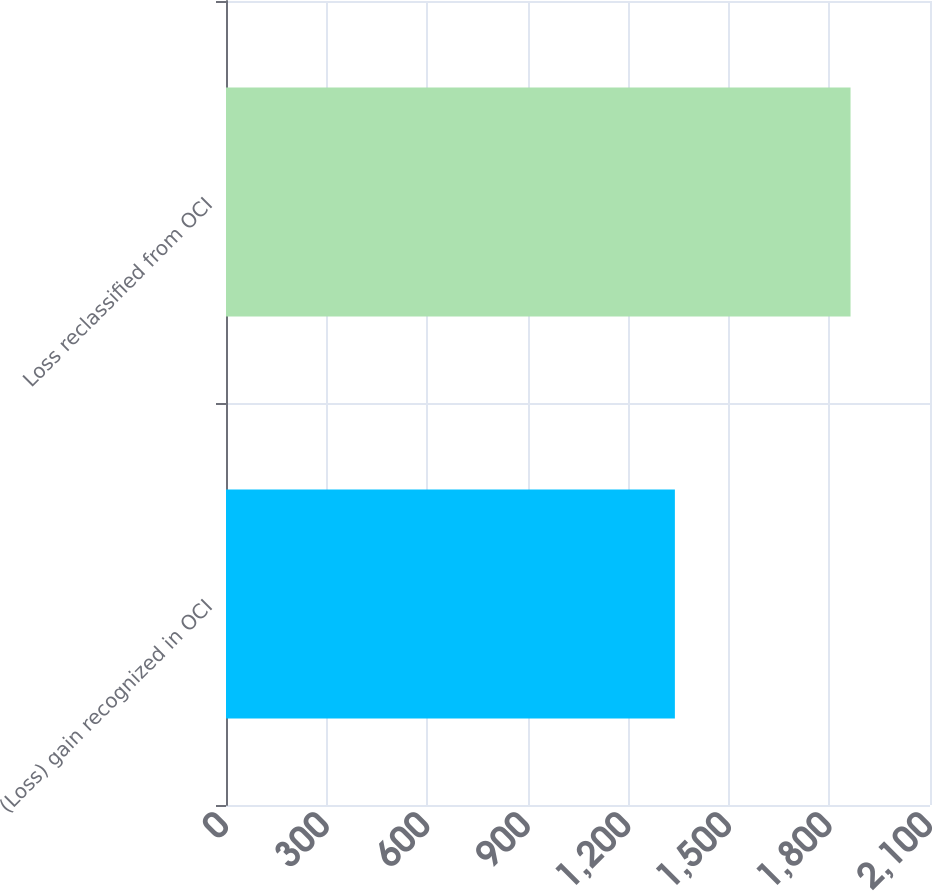<chart> <loc_0><loc_0><loc_500><loc_500><bar_chart><fcel>(Loss) gain recognized in OCI<fcel>Loss reclassified from OCI<nl><fcel>1339<fcel>1863<nl></chart> 